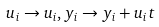<formula> <loc_0><loc_0><loc_500><loc_500>u _ { i } \rightarrow u _ { i } , y _ { i } \rightarrow y _ { i } + u _ { i } t</formula> 